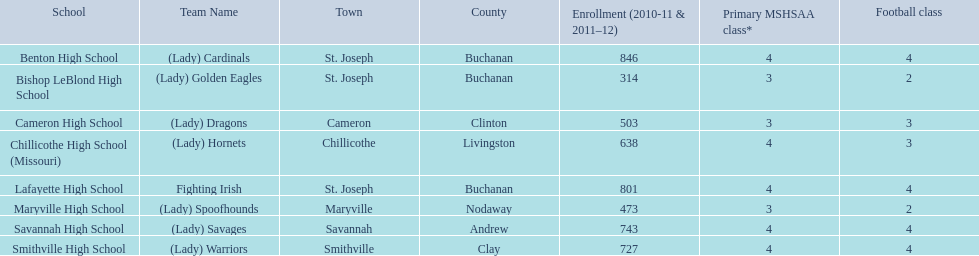How many students are registered at each educational institution? Benton High School, 846, Bishop LeBlond High School, 314, Cameron High School, 503, Chillicothe High School (Missouri), 638, Lafayette High School, 801, Maryville High School, 473, Savannah High School, 743, Smithville High School, 727. Which institution has a minimum of three football courses? Cameron High School, 3, Chillicothe High School (Missouri), 3. Which educational institution has 638 registered students and 3 football courses? Chillicothe High School (Missouri). 